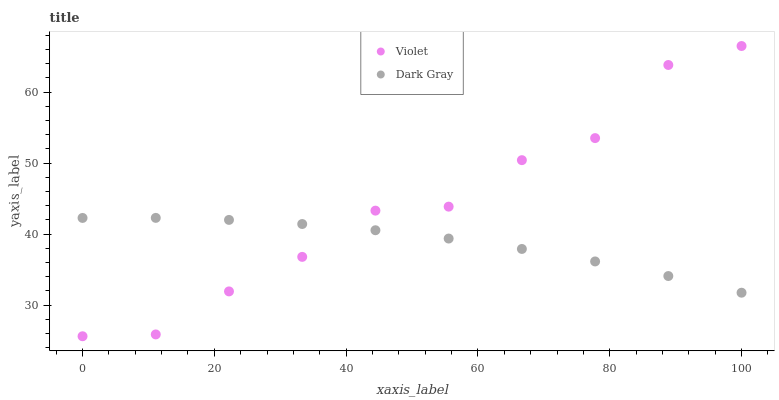Does Dark Gray have the minimum area under the curve?
Answer yes or no. Yes. Does Violet have the maximum area under the curve?
Answer yes or no. Yes. Does Violet have the minimum area under the curve?
Answer yes or no. No. Is Dark Gray the smoothest?
Answer yes or no. Yes. Is Violet the roughest?
Answer yes or no. Yes. Is Violet the smoothest?
Answer yes or no. No. Does Violet have the lowest value?
Answer yes or no. Yes. Does Violet have the highest value?
Answer yes or no. Yes. Does Violet intersect Dark Gray?
Answer yes or no. Yes. Is Violet less than Dark Gray?
Answer yes or no. No. Is Violet greater than Dark Gray?
Answer yes or no. No. 